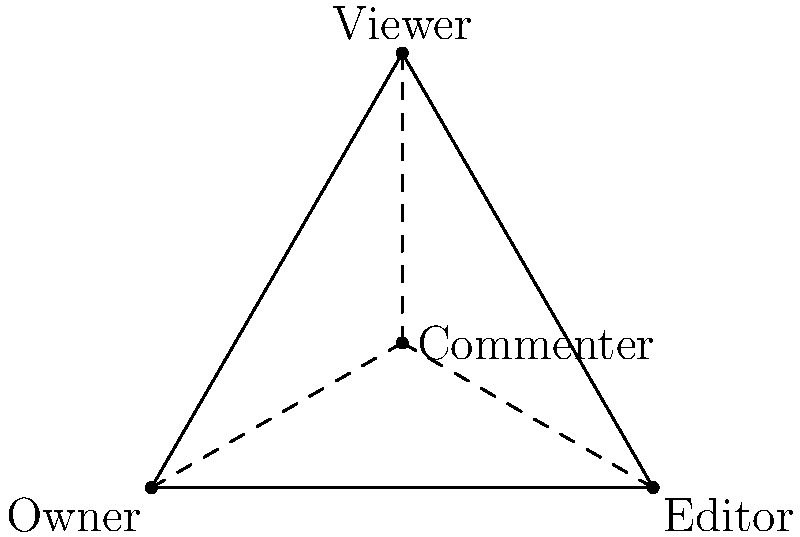In Google Drive's user role structure, which can be represented as a group, consider the roles: Owner, Editor, Viewer, and Commenter. If we define a binary operation ⊕ as "the highest common permission level", what is the result of Editor ⊕ Commenter? To solve this problem, let's follow these steps:

1. Understand the hierarchy of permissions in Google Drive:
   Owner > Editor > Commenter > Viewer

2. Define the binary operation ⊕ as "the highest common permission level":
   This means we need to find the highest role that is common to both roles being combined.

3. Analyze Editor ⊕ Commenter:
   - Editor has higher permissions than Commenter
   - The highest common permission level between Editor and Commenter is Commenter

4. Verify the group properties:
   - Closure: The result of any two elements combined is always within the set of roles
   - Associativity: (A ⊕ B) ⊕ C = A ⊕ (B ⊕ C) for any roles A, B, C
   - Identity element: Owner, as Owner ⊕ X = X for any role X
   - Inverse element: Each element is its own inverse, as X ⊕ X = X

Therefore, the result of Editor ⊕ Commenter is Commenter.
Answer: Commenter 